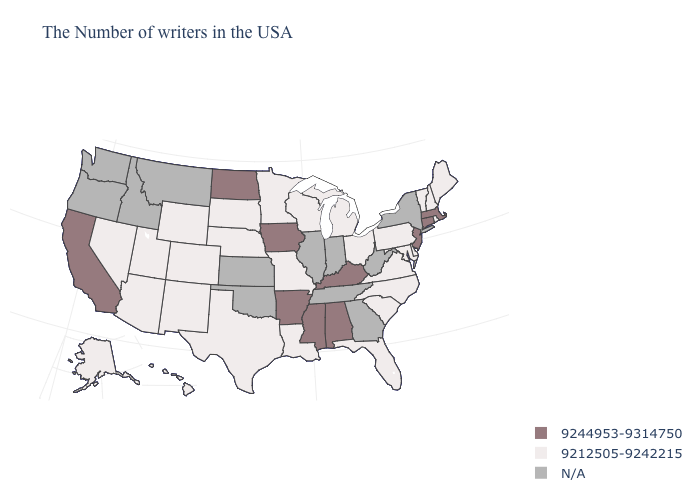Which states have the lowest value in the USA?
Write a very short answer. Maine, Rhode Island, New Hampshire, Vermont, Delaware, Maryland, Pennsylvania, Virginia, North Carolina, South Carolina, Ohio, Florida, Michigan, Wisconsin, Louisiana, Missouri, Minnesota, Nebraska, Texas, South Dakota, Wyoming, Colorado, New Mexico, Utah, Arizona, Nevada, Alaska, Hawaii. How many symbols are there in the legend?
Concise answer only. 3. Does the first symbol in the legend represent the smallest category?
Short answer required. No. Name the states that have a value in the range 9244953-9314750?
Be succinct. Massachusetts, Connecticut, New Jersey, Kentucky, Alabama, Mississippi, Arkansas, Iowa, North Dakota, California. Name the states that have a value in the range N/A?
Be succinct. New York, West Virginia, Georgia, Indiana, Tennessee, Illinois, Kansas, Oklahoma, Montana, Idaho, Washington, Oregon. Name the states that have a value in the range 9212505-9242215?
Keep it brief. Maine, Rhode Island, New Hampshire, Vermont, Delaware, Maryland, Pennsylvania, Virginia, North Carolina, South Carolina, Ohio, Florida, Michigan, Wisconsin, Louisiana, Missouri, Minnesota, Nebraska, Texas, South Dakota, Wyoming, Colorado, New Mexico, Utah, Arizona, Nevada, Alaska, Hawaii. What is the value of Wyoming?
Be succinct. 9212505-9242215. What is the value of Wyoming?
Concise answer only. 9212505-9242215. Does Colorado have the lowest value in the USA?
Quick response, please. Yes. Among the states that border Ohio , does Kentucky have the lowest value?
Quick response, please. No. Among the states that border Virginia , does Kentucky have the highest value?
Short answer required. Yes. Is the legend a continuous bar?
Write a very short answer. No. 